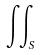Convert formula to latex. <formula><loc_0><loc_0><loc_500><loc_500>\iint _ { S }</formula> 